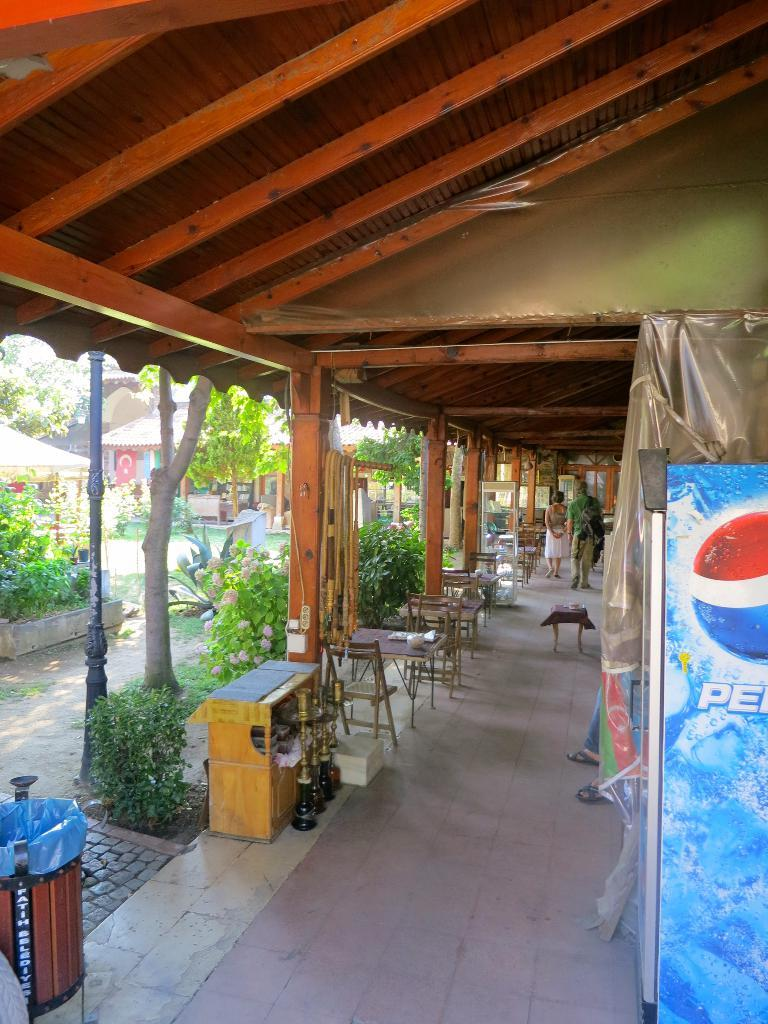Who is present in the image? There is a couple in the image. What are the couple doing in the image? The couple is walking in a corridor. Where is the corridor located? The corridor is in a restaurant. What can be seen in the corridor besides the couple? There are tables and chairs in the corridor. What is visible outside the corridor? There are plants and trees beside the corridor. the corridor. What type of bells can be heard ringing in the image? There are no bells present in the image, and therefore no sound can be heard. 